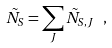Convert formula to latex. <formula><loc_0><loc_0><loc_500><loc_500>\tilde { N } _ { S } = \sum _ { J } { \tilde { N } _ { S , J } } \ ,</formula> 